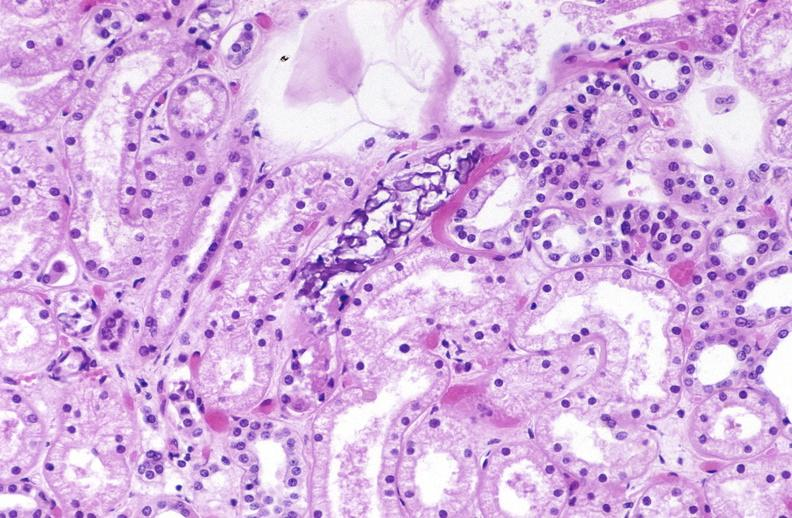does toxic epidermal necrolysis show atn and calcium deposits?
Answer the question using a single word or phrase. No 